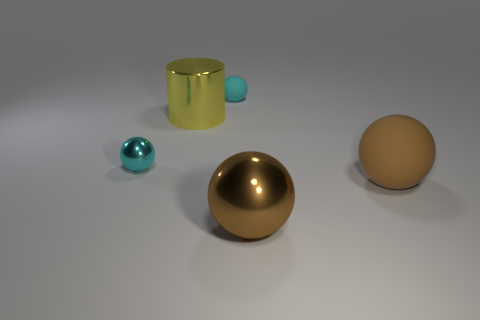Subtract all small cyan metallic spheres. How many spheres are left? 3 Add 3 gray metallic cylinders. How many objects exist? 8 Subtract all brown balls. How many balls are left? 2 Subtract all balls. How many objects are left? 1 Subtract all yellow balls. Subtract all green cubes. How many balls are left? 4 Subtract all brown cubes. How many green spheres are left? 0 Subtract all cyan rubber spheres. Subtract all cyan matte things. How many objects are left? 3 Add 5 tiny metal things. How many tiny metal things are left? 6 Add 3 small cyan metallic objects. How many small cyan metallic objects exist? 4 Subtract 0 red cylinders. How many objects are left? 5 